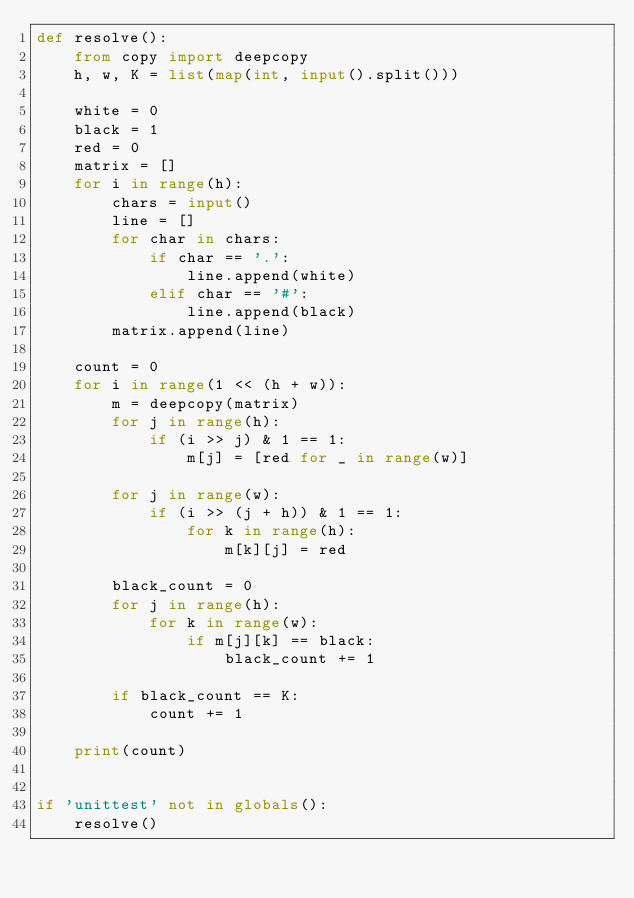Convert code to text. <code><loc_0><loc_0><loc_500><loc_500><_Python_>def resolve():
    from copy import deepcopy
    h, w, K = list(map(int, input().split()))

    white = 0
    black = 1
    red = 0
    matrix = []
    for i in range(h):
        chars = input()
        line = []
        for char in chars:
            if char == '.':
                line.append(white)
            elif char == '#':
                line.append(black)
        matrix.append(line)

    count = 0
    for i in range(1 << (h + w)):
        m = deepcopy(matrix)
        for j in range(h):
            if (i >> j) & 1 == 1:
                m[j] = [red for _ in range(w)]

        for j in range(w):
            if (i >> (j + h)) & 1 == 1:
                for k in range(h):
                    m[k][j] = red

        black_count = 0
        for j in range(h):
            for k in range(w):
                if m[j][k] == black:
                    black_count += 1

        if black_count == K:
            count += 1

    print(count)


if 'unittest' not in globals():
    resolve()</code> 